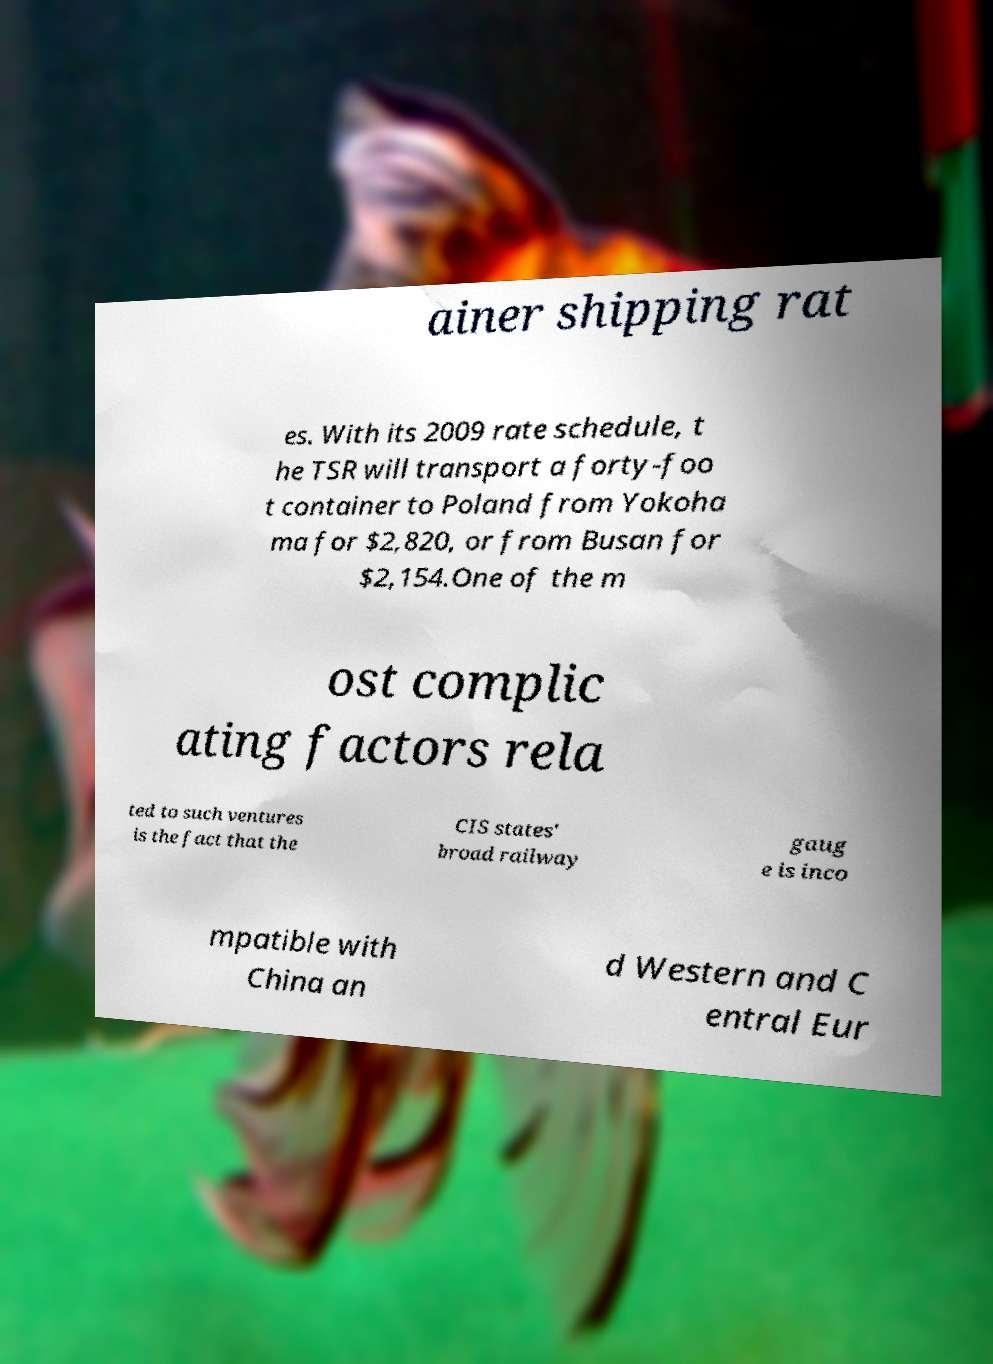Can you read and provide the text displayed in the image?This photo seems to have some interesting text. Can you extract and type it out for me? ainer shipping rat es. With its 2009 rate schedule, t he TSR will transport a forty-foo t container to Poland from Yokoha ma for $2,820, or from Busan for $2,154.One of the m ost complic ating factors rela ted to such ventures is the fact that the CIS states' broad railway gaug e is inco mpatible with China an d Western and C entral Eur 